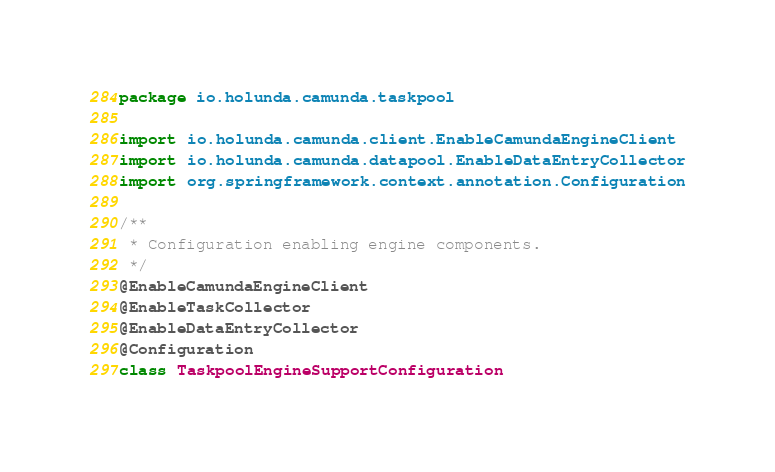Convert code to text. <code><loc_0><loc_0><loc_500><loc_500><_Kotlin_>package io.holunda.camunda.taskpool

import io.holunda.camunda.client.EnableCamundaEngineClient
import io.holunda.camunda.datapool.EnableDataEntryCollector
import org.springframework.context.annotation.Configuration

/**
 * Configuration enabling engine components.
 */
@EnableCamundaEngineClient
@EnableTaskCollector
@EnableDataEntryCollector
@Configuration
class TaskpoolEngineSupportConfiguration
</code> 